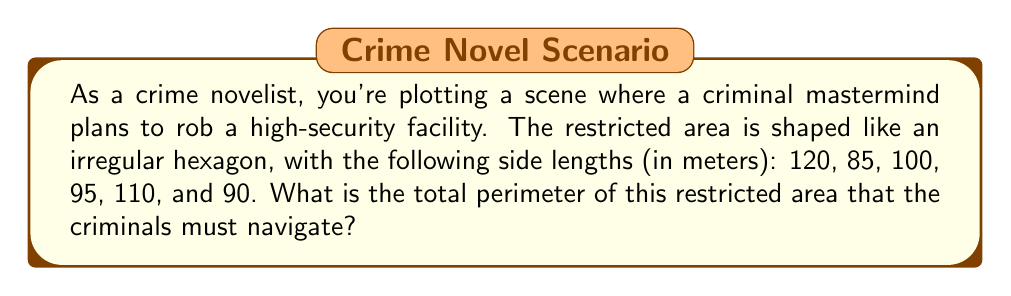Could you help me with this problem? To solve this problem, we need to calculate the perimeter of the irregular hexagon. The perimeter of a polygon is the sum of the lengths of all its sides.

Given:
- The restricted area is an irregular hexagon
- The side lengths are: 120 m, 85 m, 100 m, 95 m, 110 m, and 90 m

Let's calculate the perimeter:

$$\begin{align}
\text{Perimeter} &= s_1 + s_2 + s_3 + s_4 + s_5 + s_6 \\
&= 120 + 85 + 100 + 95 + 110 + 90 \\
&= 600 \text{ meters}
\end{align}$$

Where $s_1, s_2, ..., s_6$ represent the six sides of the hexagon.

[asy]
unitsize(0.5cm);
pair A = (0,0);
pair B = (12,0);
pair C = (16,8);
pair D = (10,12);
pair E = (0,10);
pair F = (-2,5);

draw(A--B--C--D--E--F--cycle);

label("120m", (A+B)/2, S);
label("85m", (B+C)/2, SE);
label("100m", (C+D)/2, NE);
label("95m", (D+E)/2, NW);
label("110m", (E+F)/2, W);
label("90m", (F+A)/2, SW);

dot(A); dot(B); dot(C); dot(D); dot(E); dot(F);
[/asy]

This diagram illustrates the irregular hexagon-shaped restricted area with the given side lengths.
Answer: The total perimeter of the restricted area is 600 meters. 